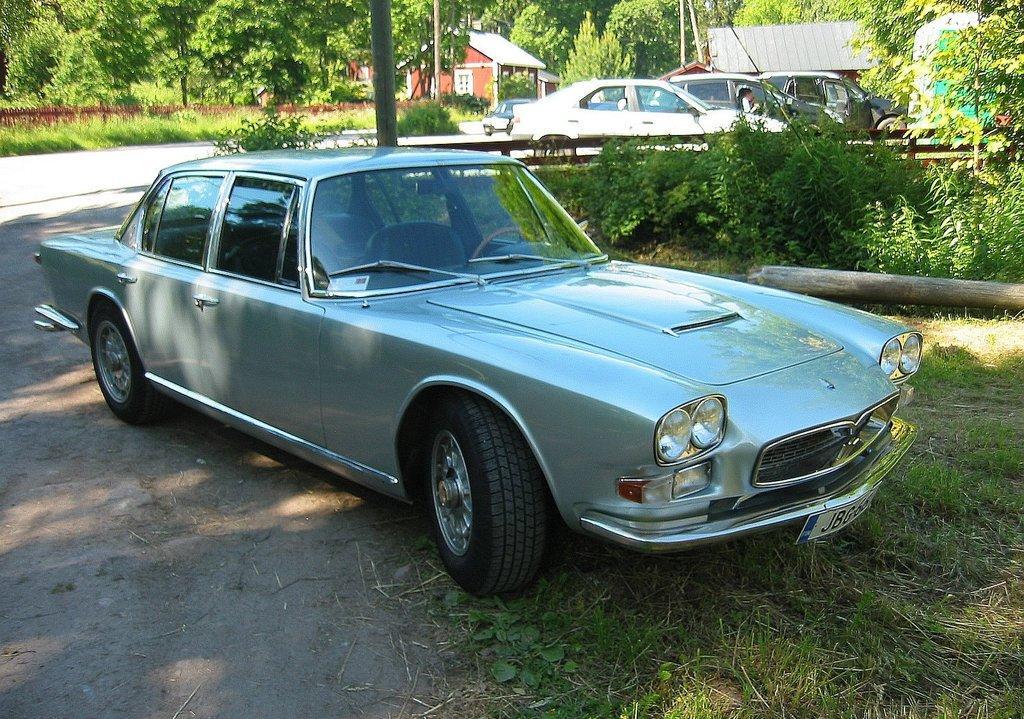Could you give a brief overview of what you see in this image? This image consists of a car. At the bottom, there is green grass on the ground. In the background, there are many cars. To the left, there is a small house along with the trees. 